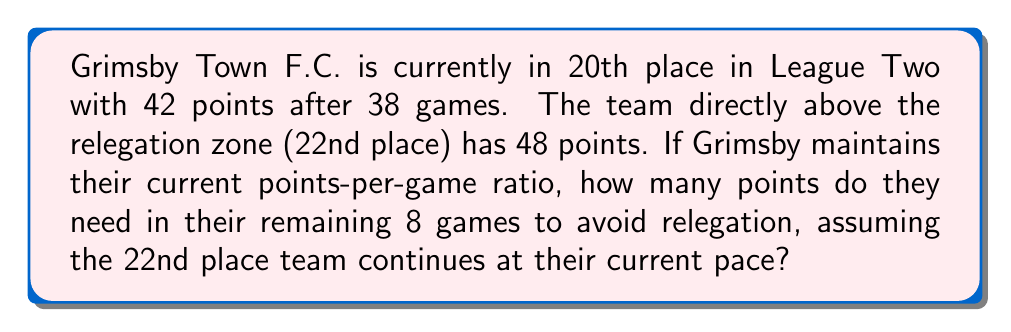Help me with this question. Let's break this down step-by-step:

1. Calculate Grimsby's current points-per-game (PPG):
   $$PPG_{Grimsby} = \frac{42 \text{ points}}{38 \text{ games}} = 1.105 \text{ PPG}$$

2. Calculate the 22nd place team's PPG:
   $$PPG_{22nd} = \frac{48 \text{ points}}{38 \text{ games}} = 1.263 \text{ PPG}$$

3. Project the 22nd place team's final points:
   $$\text{Final Points}_{22nd} = 48 + (1.263 \times 8) = 58.104 \text{ points}$$

4. Grimsby needs to exceed this, so we'll round up to 59 points.

5. Calculate how many more points Grimsby needs:
   $$\text{Points Needed} = 59 - 42 = 17 \text{ points}$$

6. Check if this is achievable in 8 games:
   $$\text{Max Possible Points} = 8 \text{ games} \times 3 \text{ points per win} = 24 \text{ points}$$

   17 points is achievable in 8 games.

Therefore, Grimsby Town F.C. needs to earn 17 points in their remaining 8 games to avoid relegation.
Answer: 17 points 